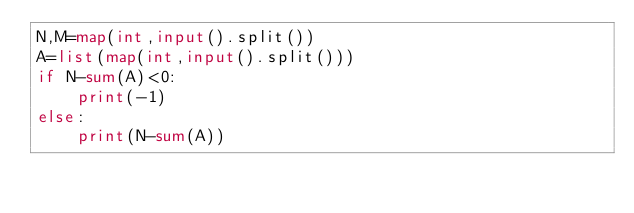Convert code to text. <code><loc_0><loc_0><loc_500><loc_500><_Python_>N,M=map(int,input().split())
A=list(map(int,input().split()))
if N-sum(A)<0:
    print(-1)
else:
    print(N-sum(A))

    







</code> 